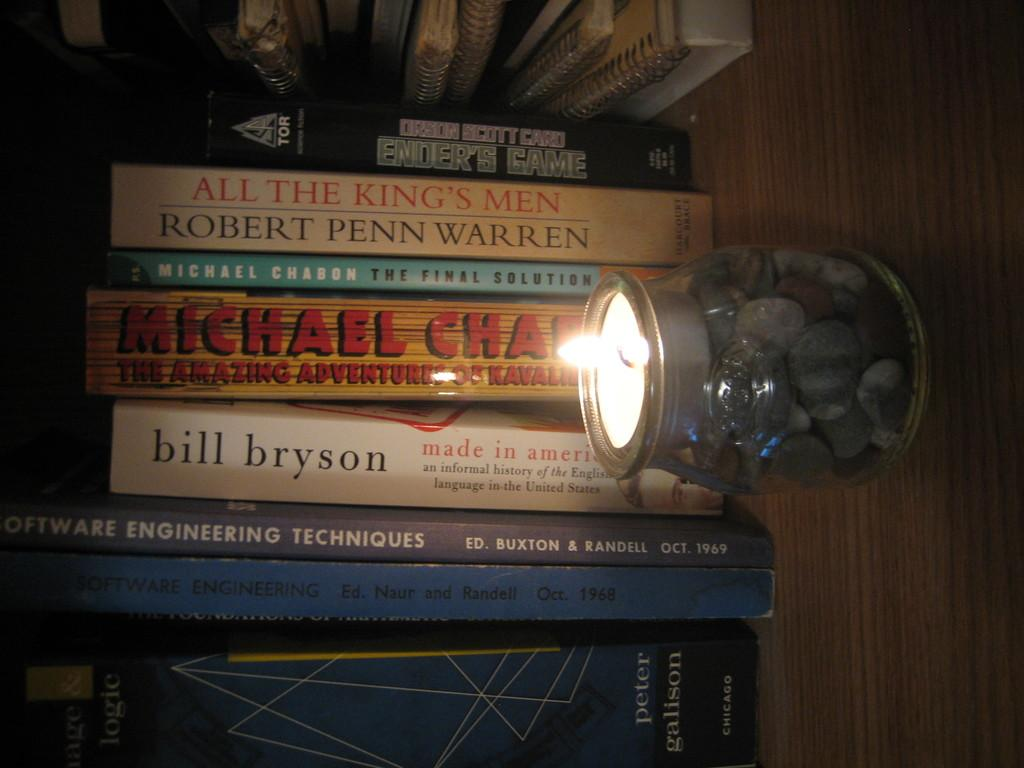What is one of the objects visible in the image? There is a candle in the image. What else can be seen in the image? There is a jar and books in the image. Can you describe the wooden surface in the image? There are other objects on a wooden surface in the image. What type of bird can be heard making noise in the image? There is no bird or noise present in the image. How many kittens are visible on the wooden surface in the image? There are no kittens present in the image. 